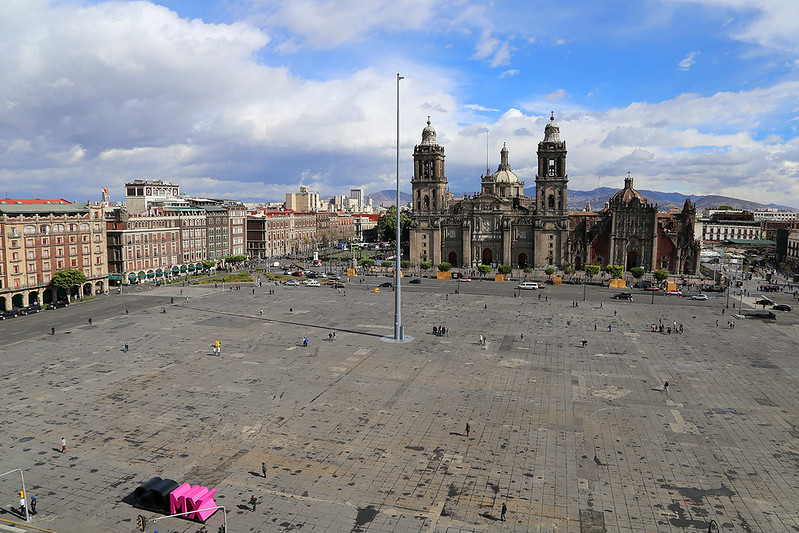Describe a realistic scenario in the Zócalo during a typical day. On a typical day, the Zócalo is a bustling hub of activity. Early morning joggers and dog walkers enjoy the open space before the city fully wakes up. As the day progresses, tourists start to gather, taking photographs and admiring the historic buildings surrounding the square.

Vendors set up stalls offering a variety of items, from traditional crafts to street food. The aroma of churros and tacos fills the air, enticing visitors to take a break and savor a taste of local cuisine. Local artists and performers set up their spaces, adding to the vibrant atmosphere with music and dance.

Office workers from the nearby buildings might pass through the square, grabbing a quick lunch or meeting friends. In the afternoon, school groups on field trips can be seen, their excited chatter blending with the hum of the city.

As evening approaches, the Zócalo becomes a focal point for social gatherings. People come to relax, chat, and enjoy the cool evening air. The lights from the surrounding buildings create a warm glow, making the historic square a picturesque and lively part of Mexico City. 